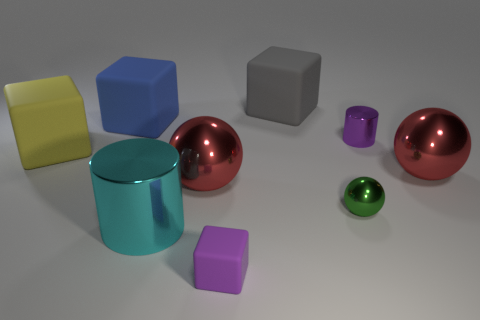Are the objects arranged in any particular pattern? The objects are not arranged in a specific pattern; they are distributed somewhat randomly across the surface. However, the spheres and the cylinder are placed more towards the right side of the image, while the big rubber cubes sit apart from each other. 